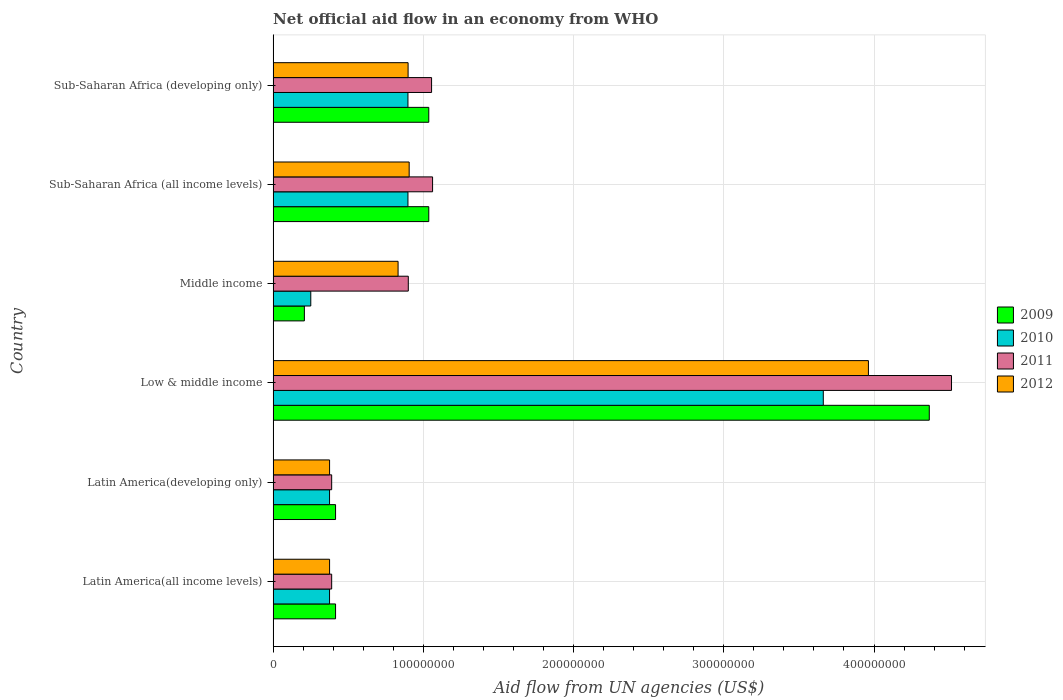How many groups of bars are there?
Ensure brevity in your answer.  6. How many bars are there on the 5th tick from the top?
Your answer should be very brief. 4. How many bars are there on the 2nd tick from the bottom?
Keep it short and to the point. 4. What is the label of the 1st group of bars from the top?
Provide a short and direct response. Sub-Saharan Africa (developing only). What is the net official aid flow in 2012 in Sub-Saharan Africa (developing only)?
Offer a terse response. 8.98e+07. Across all countries, what is the maximum net official aid flow in 2009?
Keep it short and to the point. 4.37e+08. Across all countries, what is the minimum net official aid flow in 2012?
Your answer should be very brief. 3.76e+07. In which country was the net official aid flow in 2012 minimum?
Provide a short and direct response. Latin America(all income levels). What is the total net official aid flow in 2011 in the graph?
Give a very brief answer. 8.31e+08. What is the difference between the net official aid flow in 2010 in Latin America(all income levels) and that in Sub-Saharan Africa (developing only)?
Keep it short and to the point. -5.22e+07. What is the difference between the net official aid flow in 2010 in Latin America(developing only) and the net official aid flow in 2009 in Middle income?
Your response must be concise. 1.68e+07. What is the average net official aid flow in 2010 per country?
Your answer should be very brief. 1.08e+08. What is the difference between the net official aid flow in 2010 and net official aid flow in 2012 in Middle income?
Make the answer very short. -5.81e+07. In how many countries, is the net official aid flow in 2012 greater than 40000000 US$?
Offer a terse response. 4. What is the ratio of the net official aid flow in 2010 in Latin America(developing only) to that in Sub-Saharan Africa (all income levels)?
Your answer should be very brief. 0.42. Is the net official aid flow in 2009 in Latin America(all income levels) less than that in Sub-Saharan Africa (all income levels)?
Provide a short and direct response. Yes. Is the difference between the net official aid flow in 2010 in Latin America(all income levels) and Latin America(developing only) greater than the difference between the net official aid flow in 2012 in Latin America(all income levels) and Latin America(developing only)?
Offer a terse response. No. What is the difference between the highest and the second highest net official aid flow in 2011?
Your response must be concise. 3.45e+08. What is the difference between the highest and the lowest net official aid flow in 2009?
Your answer should be very brief. 4.16e+08. In how many countries, is the net official aid flow in 2011 greater than the average net official aid flow in 2011 taken over all countries?
Give a very brief answer. 1. Is the sum of the net official aid flow in 2011 in Latin America(all income levels) and Latin America(developing only) greater than the maximum net official aid flow in 2012 across all countries?
Ensure brevity in your answer.  No. Is it the case that in every country, the sum of the net official aid flow in 2009 and net official aid flow in 2010 is greater than the sum of net official aid flow in 2012 and net official aid flow in 2011?
Make the answer very short. No. What does the 4th bar from the top in Low & middle income represents?
Offer a terse response. 2009. What does the 3rd bar from the bottom in Middle income represents?
Your response must be concise. 2011. How many bars are there?
Ensure brevity in your answer.  24. Where does the legend appear in the graph?
Your response must be concise. Center right. How many legend labels are there?
Ensure brevity in your answer.  4. How are the legend labels stacked?
Your answer should be compact. Vertical. What is the title of the graph?
Offer a very short reply. Net official aid flow in an economy from WHO. Does "1988" appear as one of the legend labels in the graph?
Your answer should be compact. No. What is the label or title of the X-axis?
Your answer should be very brief. Aid flow from UN agencies (US$). What is the Aid flow from UN agencies (US$) of 2009 in Latin America(all income levels)?
Offer a terse response. 4.16e+07. What is the Aid flow from UN agencies (US$) of 2010 in Latin America(all income levels)?
Ensure brevity in your answer.  3.76e+07. What is the Aid flow from UN agencies (US$) in 2011 in Latin America(all income levels)?
Your response must be concise. 3.90e+07. What is the Aid flow from UN agencies (US$) in 2012 in Latin America(all income levels)?
Keep it short and to the point. 3.76e+07. What is the Aid flow from UN agencies (US$) of 2009 in Latin America(developing only)?
Your answer should be compact. 4.16e+07. What is the Aid flow from UN agencies (US$) of 2010 in Latin America(developing only)?
Your answer should be compact. 3.76e+07. What is the Aid flow from UN agencies (US$) of 2011 in Latin America(developing only)?
Give a very brief answer. 3.90e+07. What is the Aid flow from UN agencies (US$) in 2012 in Latin America(developing only)?
Keep it short and to the point. 3.76e+07. What is the Aid flow from UN agencies (US$) of 2009 in Low & middle income?
Give a very brief answer. 4.37e+08. What is the Aid flow from UN agencies (US$) of 2010 in Low & middle income?
Your answer should be compact. 3.66e+08. What is the Aid flow from UN agencies (US$) of 2011 in Low & middle income?
Your answer should be compact. 4.52e+08. What is the Aid flow from UN agencies (US$) in 2012 in Low & middle income?
Your answer should be very brief. 3.96e+08. What is the Aid flow from UN agencies (US$) of 2009 in Middle income?
Your answer should be very brief. 2.08e+07. What is the Aid flow from UN agencies (US$) of 2010 in Middle income?
Keep it short and to the point. 2.51e+07. What is the Aid flow from UN agencies (US$) of 2011 in Middle income?
Your answer should be compact. 9.00e+07. What is the Aid flow from UN agencies (US$) in 2012 in Middle income?
Keep it short and to the point. 8.32e+07. What is the Aid flow from UN agencies (US$) of 2009 in Sub-Saharan Africa (all income levels)?
Provide a succinct answer. 1.04e+08. What is the Aid flow from UN agencies (US$) of 2010 in Sub-Saharan Africa (all income levels)?
Your answer should be very brief. 8.98e+07. What is the Aid flow from UN agencies (US$) in 2011 in Sub-Saharan Africa (all income levels)?
Make the answer very short. 1.06e+08. What is the Aid flow from UN agencies (US$) of 2012 in Sub-Saharan Africa (all income levels)?
Provide a short and direct response. 9.06e+07. What is the Aid flow from UN agencies (US$) of 2009 in Sub-Saharan Africa (developing only)?
Ensure brevity in your answer.  1.04e+08. What is the Aid flow from UN agencies (US$) in 2010 in Sub-Saharan Africa (developing only)?
Provide a short and direct response. 8.98e+07. What is the Aid flow from UN agencies (US$) of 2011 in Sub-Saharan Africa (developing only)?
Provide a succinct answer. 1.05e+08. What is the Aid flow from UN agencies (US$) of 2012 in Sub-Saharan Africa (developing only)?
Offer a terse response. 8.98e+07. Across all countries, what is the maximum Aid flow from UN agencies (US$) of 2009?
Offer a terse response. 4.37e+08. Across all countries, what is the maximum Aid flow from UN agencies (US$) of 2010?
Offer a terse response. 3.66e+08. Across all countries, what is the maximum Aid flow from UN agencies (US$) in 2011?
Your response must be concise. 4.52e+08. Across all countries, what is the maximum Aid flow from UN agencies (US$) in 2012?
Make the answer very short. 3.96e+08. Across all countries, what is the minimum Aid flow from UN agencies (US$) of 2009?
Make the answer very short. 2.08e+07. Across all countries, what is the minimum Aid flow from UN agencies (US$) of 2010?
Offer a terse response. 2.51e+07. Across all countries, what is the minimum Aid flow from UN agencies (US$) in 2011?
Your answer should be compact. 3.90e+07. Across all countries, what is the minimum Aid flow from UN agencies (US$) of 2012?
Make the answer very short. 3.76e+07. What is the total Aid flow from UN agencies (US$) of 2009 in the graph?
Make the answer very short. 7.48e+08. What is the total Aid flow from UN agencies (US$) in 2010 in the graph?
Provide a succinct answer. 6.46e+08. What is the total Aid flow from UN agencies (US$) in 2011 in the graph?
Make the answer very short. 8.31e+08. What is the total Aid flow from UN agencies (US$) in 2012 in the graph?
Give a very brief answer. 7.35e+08. What is the difference between the Aid flow from UN agencies (US$) of 2010 in Latin America(all income levels) and that in Latin America(developing only)?
Keep it short and to the point. 0. What is the difference between the Aid flow from UN agencies (US$) of 2011 in Latin America(all income levels) and that in Latin America(developing only)?
Provide a succinct answer. 0. What is the difference between the Aid flow from UN agencies (US$) in 2009 in Latin America(all income levels) and that in Low & middle income?
Your answer should be compact. -3.95e+08. What is the difference between the Aid flow from UN agencies (US$) in 2010 in Latin America(all income levels) and that in Low & middle income?
Provide a succinct answer. -3.29e+08. What is the difference between the Aid flow from UN agencies (US$) in 2011 in Latin America(all income levels) and that in Low & middle income?
Offer a terse response. -4.13e+08. What is the difference between the Aid flow from UN agencies (US$) in 2012 in Latin America(all income levels) and that in Low & middle income?
Make the answer very short. -3.59e+08. What is the difference between the Aid flow from UN agencies (US$) of 2009 in Latin America(all income levels) and that in Middle income?
Your answer should be very brief. 2.08e+07. What is the difference between the Aid flow from UN agencies (US$) of 2010 in Latin America(all income levels) and that in Middle income?
Offer a terse response. 1.25e+07. What is the difference between the Aid flow from UN agencies (US$) in 2011 in Latin America(all income levels) and that in Middle income?
Offer a terse response. -5.10e+07. What is the difference between the Aid flow from UN agencies (US$) of 2012 in Latin America(all income levels) and that in Middle income?
Give a very brief answer. -4.56e+07. What is the difference between the Aid flow from UN agencies (US$) in 2009 in Latin America(all income levels) and that in Sub-Saharan Africa (all income levels)?
Ensure brevity in your answer.  -6.20e+07. What is the difference between the Aid flow from UN agencies (US$) in 2010 in Latin America(all income levels) and that in Sub-Saharan Africa (all income levels)?
Your response must be concise. -5.22e+07. What is the difference between the Aid flow from UN agencies (US$) of 2011 in Latin America(all income levels) and that in Sub-Saharan Africa (all income levels)?
Offer a terse response. -6.72e+07. What is the difference between the Aid flow from UN agencies (US$) of 2012 in Latin America(all income levels) and that in Sub-Saharan Africa (all income levels)?
Keep it short and to the point. -5.30e+07. What is the difference between the Aid flow from UN agencies (US$) of 2009 in Latin America(all income levels) and that in Sub-Saharan Africa (developing only)?
Your answer should be compact. -6.20e+07. What is the difference between the Aid flow from UN agencies (US$) in 2010 in Latin America(all income levels) and that in Sub-Saharan Africa (developing only)?
Offer a terse response. -5.22e+07. What is the difference between the Aid flow from UN agencies (US$) in 2011 in Latin America(all income levels) and that in Sub-Saharan Africa (developing only)?
Offer a very short reply. -6.65e+07. What is the difference between the Aid flow from UN agencies (US$) of 2012 in Latin America(all income levels) and that in Sub-Saharan Africa (developing only)?
Provide a short and direct response. -5.23e+07. What is the difference between the Aid flow from UN agencies (US$) of 2009 in Latin America(developing only) and that in Low & middle income?
Make the answer very short. -3.95e+08. What is the difference between the Aid flow from UN agencies (US$) in 2010 in Latin America(developing only) and that in Low & middle income?
Ensure brevity in your answer.  -3.29e+08. What is the difference between the Aid flow from UN agencies (US$) in 2011 in Latin America(developing only) and that in Low & middle income?
Offer a very short reply. -4.13e+08. What is the difference between the Aid flow from UN agencies (US$) in 2012 in Latin America(developing only) and that in Low & middle income?
Your answer should be compact. -3.59e+08. What is the difference between the Aid flow from UN agencies (US$) of 2009 in Latin America(developing only) and that in Middle income?
Ensure brevity in your answer.  2.08e+07. What is the difference between the Aid flow from UN agencies (US$) in 2010 in Latin America(developing only) and that in Middle income?
Give a very brief answer. 1.25e+07. What is the difference between the Aid flow from UN agencies (US$) in 2011 in Latin America(developing only) and that in Middle income?
Offer a terse response. -5.10e+07. What is the difference between the Aid flow from UN agencies (US$) of 2012 in Latin America(developing only) and that in Middle income?
Offer a very short reply. -4.56e+07. What is the difference between the Aid flow from UN agencies (US$) in 2009 in Latin America(developing only) and that in Sub-Saharan Africa (all income levels)?
Your response must be concise. -6.20e+07. What is the difference between the Aid flow from UN agencies (US$) of 2010 in Latin America(developing only) and that in Sub-Saharan Africa (all income levels)?
Your response must be concise. -5.22e+07. What is the difference between the Aid flow from UN agencies (US$) in 2011 in Latin America(developing only) and that in Sub-Saharan Africa (all income levels)?
Give a very brief answer. -6.72e+07. What is the difference between the Aid flow from UN agencies (US$) of 2012 in Latin America(developing only) and that in Sub-Saharan Africa (all income levels)?
Your answer should be compact. -5.30e+07. What is the difference between the Aid flow from UN agencies (US$) in 2009 in Latin America(developing only) and that in Sub-Saharan Africa (developing only)?
Your response must be concise. -6.20e+07. What is the difference between the Aid flow from UN agencies (US$) of 2010 in Latin America(developing only) and that in Sub-Saharan Africa (developing only)?
Provide a short and direct response. -5.22e+07. What is the difference between the Aid flow from UN agencies (US$) in 2011 in Latin America(developing only) and that in Sub-Saharan Africa (developing only)?
Your answer should be very brief. -6.65e+07. What is the difference between the Aid flow from UN agencies (US$) of 2012 in Latin America(developing only) and that in Sub-Saharan Africa (developing only)?
Give a very brief answer. -5.23e+07. What is the difference between the Aid flow from UN agencies (US$) of 2009 in Low & middle income and that in Middle income?
Your answer should be very brief. 4.16e+08. What is the difference between the Aid flow from UN agencies (US$) in 2010 in Low & middle income and that in Middle income?
Provide a short and direct response. 3.41e+08. What is the difference between the Aid flow from UN agencies (US$) in 2011 in Low & middle income and that in Middle income?
Make the answer very short. 3.62e+08. What is the difference between the Aid flow from UN agencies (US$) in 2012 in Low & middle income and that in Middle income?
Offer a very short reply. 3.13e+08. What is the difference between the Aid flow from UN agencies (US$) in 2009 in Low & middle income and that in Sub-Saharan Africa (all income levels)?
Your answer should be compact. 3.33e+08. What is the difference between the Aid flow from UN agencies (US$) of 2010 in Low & middle income and that in Sub-Saharan Africa (all income levels)?
Provide a succinct answer. 2.76e+08. What is the difference between the Aid flow from UN agencies (US$) in 2011 in Low & middle income and that in Sub-Saharan Africa (all income levels)?
Your response must be concise. 3.45e+08. What is the difference between the Aid flow from UN agencies (US$) in 2012 in Low & middle income and that in Sub-Saharan Africa (all income levels)?
Give a very brief answer. 3.06e+08. What is the difference between the Aid flow from UN agencies (US$) of 2009 in Low & middle income and that in Sub-Saharan Africa (developing only)?
Provide a short and direct response. 3.33e+08. What is the difference between the Aid flow from UN agencies (US$) of 2010 in Low & middle income and that in Sub-Saharan Africa (developing only)?
Provide a short and direct response. 2.76e+08. What is the difference between the Aid flow from UN agencies (US$) of 2011 in Low & middle income and that in Sub-Saharan Africa (developing only)?
Your answer should be compact. 3.46e+08. What is the difference between the Aid flow from UN agencies (US$) in 2012 in Low & middle income and that in Sub-Saharan Africa (developing only)?
Your answer should be compact. 3.06e+08. What is the difference between the Aid flow from UN agencies (US$) of 2009 in Middle income and that in Sub-Saharan Africa (all income levels)?
Keep it short and to the point. -8.28e+07. What is the difference between the Aid flow from UN agencies (US$) in 2010 in Middle income and that in Sub-Saharan Africa (all income levels)?
Keep it short and to the point. -6.47e+07. What is the difference between the Aid flow from UN agencies (US$) of 2011 in Middle income and that in Sub-Saharan Africa (all income levels)?
Keep it short and to the point. -1.62e+07. What is the difference between the Aid flow from UN agencies (US$) in 2012 in Middle income and that in Sub-Saharan Africa (all income levels)?
Ensure brevity in your answer.  -7.39e+06. What is the difference between the Aid flow from UN agencies (US$) of 2009 in Middle income and that in Sub-Saharan Africa (developing only)?
Your answer should be very brief. -8.28e+07. What is the difference between the Aid flow from UN agencies (US$) of 2010 in Middle income and that in Sub-Saharan Africa (developing only)?
Your answer should be very brief. -6.47e+07. What is the difference between the Aid flow from UN agencies (US$) in 2011 in Middle income and that in Sub-Saharan Africa (developing only)?
Offer a very short reply. -1.55e+07. What is the difference between the Aid flow from UN agencies (US$) in 2012 in Middle income and that in Sub-Saharan Africa (developing only)?
Provide a succinct answer. -6.67e+06. What is the difference between the Aid flow from UN agencies (US$) of 2009 in Sub-Saharan Africa (all income levels) and that in Sub-Saharan Africa (developing only)?
Keep it short and to the point. 0. What is the difference between the Aid flow from UN agencies (US$) in 2011 in Sub-Saharan Africa (all income levels) and that in Sub-Saharan Africa (developing only)?
Give a very brief answer. 6.70e+05. What is the difference between the Aid flow from UN agencies (US$) in 2012 in Sub-Saharan Africa (all income levels) and that in Sub-Saharan Africa (developing only)?
Provide a short and direct response. 7.20e+05. What is the difference between the Aid flow from UN agencies (US$) of 2009 in Latin America(all income levels) and the Aid flow from UN agencies (US$) of 2010 in Latin America(developing only)?
Offer a terse response. 4.01e+06. What is the difference between the Aid flow from UN agencies (US$) in 2009 in Latin America(all income levels) and the Aid flow from UN agencies (US$) in 2011 in Latin America(developing only)?
Your answer should be very brief. 2.59e+06. What is the difference between the Aid flow from UN agencies (US$) in 2009 in Latin America(all income levels) and the Aid flow from UN agencies (US$) in 2012 in Latin America(developing only)?
Make the answer very short. 3.99e+06. What is the difference between the Aid flow from UN agencies (US$) of 2010 in Latin America(all income levels) and the Aid flow from UN agencies (US$) of 2011 in Latin America(developing only)?
Provide a succinct answer. -1.42e+06. What is the difference between the Aid flow from UN agencies (US$) in 2011 in Latin America(all income levels) and the Aid flow from UN agencies (US$) in 2012 in Latin America(developing only)?
Make the answer very short. 1.40e+06. What is the difference between the Aid flow from UN agencies (US$) of 2009 in Latin America(all income levels) and the Aid flow from UN agencies (US$) of 2010 in Low & middle income?
Give a very brief answer. -3.25e+08. What is the difference between the Aid flow from UN agencies (US$) of 2009 in Latin America(all income levels) and the Aid flow from UN agencies (US$) of 2011 in Low & middle income?
Provide a succinct answer. -4.10e+08. What is the difference between the Aid flow from UN agencies (US$) of 2009 in Latin America(all income levels) and the Aid flow from UN agencies (US$) of 2012 in Low & middle income?
Provide a short and direct response. -3.55e+08. What is the difference between the Aid flow from UN agencies (US$) of 2010 in Latin America(all income levels) and the Aid flow from UN agencies (US$) of 2011 in Low & middle income?
Provide a short and direct response. -4.14e+08. What is the difference between the Aid flow from UN agencies (US$) in 2010 in Latin America(all income levels) and the Aid flow from UN agencies (US$) in 2012 in Low & middle income?
Make the answer very short. -3.59e+08. What is the difference between the Aid flow from UN agencies (US$) in 2011 in Latin America(all income levels) and the Aid flow from UN agencies (US$) in 2012 in Low & middle income?
Your answer should be compact. -3.57e+08. What is the difference between the Aid flow from UN agencies (US$) in 2009 in Latin America(all income levels) and the Aid flow from UN agencies (US$) in 2010 in Middle income?
Your answer should be very brief. 1.65e+07. What is the difference between the Aid flow from UN agencies (US$) in 2009 in Latin America(all income levels) and the Aid flow from UN agencies (US$) in 2011 in Middle income?
Offer a very short reply. -4.84e+07. What is the difference between the Aid flow from UN agencies (US$) in 2009 in Latin America(all income levels) and the Aid flow from UN agencies (US$) in 2012 in Middle income?
Provide a short and direct response. -4.16e+07. What is the difference between the Aid flow from UN agencies (US$) in 2010 in Latin America(all income levels) and the Aid flow from UN agencies (US$) in 2011 in Middle income?
Your answer should be compact. -5.24e+07. What is the difference between the Aid flow from UN agencies (US$) in 2010 in Latin America(all income levels) and the Aid flow from UN agencies (US$) in 2012 in Middle income?
Make the answer very short. -4.56e+07. What is the difference between the Aid flow from UN agencies (US$) of 2011 in Latin America(all income levels) and the Aid flow from UN agencies (US$) of 2012 in Middle income?
Offer a terse response. -4.42e+07. What is the difference between the Aid flow from UN agencies (US$) of 2009 in Latin America(all income levels) and the Aid flow from UN agencies (US$) of 2010 in Sub-Saharan Africa (all income levels)?
Provide a short and direct response. -4.82e+07. What is the difference between the Aid flow from UN agencies (US$) in 2009 in Latin America(all income levels) and the Aid flow from UN agencies (US$) in 2011 in Sub-Saharan Africa (all income levels)?
Provide a short and direct response. -6.46e+07. What is the difference between the Aid flow from UN agencies (US$) of 2009 in Latin America(all income levels) and the Aid flow from UN agencies (US$) of 2012 in Sub-Saharan Africa (all income levels)?
Provide a succinct answer. -4.90e+07. What is the difference between the Aid flow from UN agencies (US$) of 2010 in Latin America(all income levels) and the Aid flow from UN agencies (US$) of 2011 in Sub-Saharan Africa (all income levels)?
Offer a very short reply. -6.86e+07. What is the difference between the Aid flow from UN agencies (US$) of 2010 in Latin America(all income levels) and the Aid flow from UN agencies (US$) of 2012 in Sub-Saharan Africa (all income levels)?
Provide a succinct answer. -5.30e+07. What is the difference between the Aid flow from UN agencies (US$) in 2011 in Latin America(all income levels) and the Aid flow from UN agencies (US$) in 2012 in Sub-Saharan Africa (all income levels)?
Your response must be concise. -5.16e+07. What is the difference between the Aid flow from UN agencies (US$) of 2009 in Latin America(all income levels) and the Aid flow from UN agencies (US$) of 2010 in Sub-Saharan Africa (developing only)?
Make the answer very short. -4.82e+07. What is the difference between the Aid flow from UN agencies (US$) in 2009 in Latin America(all income levels) and the Aid flow from UN agencies (US$) in 2011 in Sub-Saharan Africa (developing only)?
Your response must be concise. -6.39e+07. What is the difference between the Aid flow from UN agencies (US$) in 2009 in Latin America(all income levels) and the Aid flow from UN agencies (US$) in 2012 in Sub-Saharan Africa (developing only)?
Your answer should be very brief. -4.83e+07. What is the difference between the Aid flow from UN agencies (US$) of 2010 in Latin America(all income levels) and the Aid flow from UN agencies (US$) of 2011 in Sub-Saharan Africa (developing only)?
Provide a short and direct response. -6.79e+07. What is the difference between the Aid flow from UN agencies (US$) of 2010 in Latin America(all income levels) and the Aid flow from UN agencies (US$) of 2012 in Sub-Saharan Africa (developing only)?
Keep it short and to the point. -5.23e+07. What is the difference between the Aid flow from UN agencies (US$) in 2011 in Latin America(all income levels) and the Aid flow from UN agencies (US$) in 2012 in Sub-Saharan Africa (developing only)?
Provide a short and direct response. -5.09e+07. What is the difference between the Aid flow from UN agencies (US$) in 2009 in Latin America(developing only) and the Aid flow from UN agencies (US$) in 2010 in Low & middle income?
Your response must be concise. -3.25e+08. What is the difference between the Aid flow from UN agencies (US$) of 2009 in Latin America(developing only) and the Aid flow from UN agencies (US$) of 2011 in Low & middle income?
Keep it short and to the point. -4.10e+08. What is the difference between the Aid flow from UN agencies (US$) in 2009 in Latin America(developing only) and the Aid flow from UN agencies (US$) in 2012 in Low & middle income?
Provide a short and direct response. -3.55e+08. What is the difference between the Aid flow from UN agencies (US$) in 2010 in Latin America(developing only) and the Aid flow from UN agencies (US$) in 2011 in Low & middle income?
Offer a terse response. -4.14e+08. What is the difference between the Aid flow from UN agencies (US$) in 2010 in Latin America(developing only) and the Aid flow from UN agencies (US$) in 2012 in Low & middle income?
Keep it short and to the point. -3.59e+08. What is the difference between the Aid flow from UN agencies (US$) in 2011 in Latin America(developing only) and the Aid flow from UN agencies (US$) in 2012 in Low & middle income?
Offer a very short reply. -3.57e+08. What is the difference between the Aid flow from UN agencies (US$) of 2009 in Latin America(developing only) and the Aid flow from UN agencies (US$) of 2010 in Middle income?
Your response must be concise. 1.65e+07. What is the difference between the Aid flow from UN agencies (US$) in 2009 in Latin America(developing only) and the Aid flow from UN agencies (US$) in 2011 in Middle income?
Offer a terse response. -4.84e+07. What is the difference between the Aid flow from UN agencies (US$) in 2009 in Latin America(developing only) and the Aid flow from UN agencies (US$) in 2012 in Middle income?
Offer a very short reply. -4.16e+07. What is the difference between the Aid flow from UN agencies (US$) in 2010 in Latin America(developing only) and the Aid flow from UN agencies (US$) in 2011 in Middle income?
Your answer should be very brief. -5.24e+07. What is the difference between the Aid flow from UN agencies (US$) of 2010 in Latin America(developing only) and the Aid flow from UN agencies (US$) of 2012 in Middle income?
Your answer should be compact. -4.56e+07. What is the difference between the Aid flow from UN agencies (US$) of 2011 in Latin America(developing only) and the Aid flow from UN agencies (US$) of 2012 in Middle income?
Offer a terse response. -4.42e+07. What is the difference between the Aid flow from UN agencies (US$) in 2009 in Latin America(developing only) and the Aid flow from UN agencies (US$) in 2010 in Sub-Saharan Africa (all income levels)?
Make the answer very short. -4.82e+07. What is the difference between the Aid flow from UN agencies (US$) of 2009 in Latin America(developing only) and the Aid flow from UN agencies (US$) of 2011 in Sub-Saharan Africa (all income levels)?
Provide a succinct answer. -6.46e+07. What is the difference between the Aid flow from UN agencies (US$) in 2009 in Latin America(developing only) and the Aid flow from UN agencies (US$) in 2012 in Sub-Saharan Africa (all income levels)?
Provide a short and direct response. -4.90e+07. What is the difference between the Aid flow from UN agencies (US$) in 2010 in Latin America(developing only) and the Aid flow from UN agencies (US$) in 2011 in Sub-Saharan Africa (all income levels)?
Your answer should be compact. -6.86e+07. What is the difference between the Aid flow from UN agencies (US$) of 2010 in Latin America(developing only) and the Aid flow from UN agencies (US$) of 2012 in Sub-Saharan Africa (all income levels)?
Ensure brevity in your answer.  -5.30e+07. What is the difference between the Aid flow from UN agencies (US$) of 2011 in Latin America(developing only) and the Aid flow from UN agencies (US$) of 2012 in Sub-Saharan Africa (all income levels)?
Your answer should be very brief. -5.16e+07. What is the difference between the Aid flow from UN agencies (US$) of 2009 in Latin America(developing only) and the Aid flow from UN agencies (US$) of 2010 in Sub-Saharan Africa (developing only)?
Offer a terse response. -4.82e+07. What is the difference between the Aid flow from UN agencies (US$) of 2009 in Latin America(developing only) and the Aid flow from UN agencies (US$) of 2011 in Sub-Saharan Africa (developing only)?
Provide a succinct answer. -6.39e+07. What is the difference between the Aid flow from UN agencies (US$) in 2009 in Latin America(developing only) and the Aid flow from UN agencies (US$) in 2012 in Sub-Saharan Africa (developing only)?
Make the answer very short. -4.83e+07. What is the difference between the Aid flow from UN agencies (US$) in 2010 in Latin America(developing only) and the Aid flow from UN agencies (US$) in 2011 in Sub-Saharan Africa (developing only)?
Ensure brevity in your answer.  -6.79e+07. What is the difference between the Aid flow from UN agencies (US$) of 2010 in Latin America(developing only) and the Aid flow from UN agencies (US$) of 2012 in Sub-Saharan Africa (developing only)?
Your answer should be compact. -5.23e+07. What is the difference between the Aid flow from UN agencies (US$) in 2011 in Latin America(developing only) and the Aid flow from UN agencies (US$) in 2012 in Sub-Saharan Africa (developing only)?
Your answer should be very brief. -5.09e+07. What is the difference between the Aid flow from UN agencies (US$) of 2009 in Low & middle income and the Aid flow from UN agencies (US$) of 2010 in Middle income?
Provide a short and direct response. 4.12e+08. What is the difference between the Aid flow from UN agencies (US$) in 2009 in Low & middle income and the Aid flow from UN agencies (US$) in 2011 in Middle income?
Offer a terse response. 3.47e+08. What is the difference between the Aid flow from UN agencies (US$) in 2009 in Low & middle income and the Aid flow from UN agencies (US$) in 2012 in Middle income?
Make the answer very short. 3.54e+08. What is the difference between the Aid flow from UN agencies (US$) in 2010 in Low & middle income and the Aid flow from UN agencies (US$) in 2011 in Middle income?
Offer a very short reply. 2.76e+08. What is the difference between the Aid flow from UN agencies (US$) in 2010 in Low & middle income and the Aid flow from UN agencies (US$) in 2012 in Middle income?
Provide a short and direct response. 2.83e+08. What is the difference between the Aid flow from UN agencies (US$) of 2011 in Low & middle income and the Aid flow from UN agencies (US$) of 2012 in Middle income?
Your answer should be compact. 3.68e+08. What is the difference between the Aid flow from UN agencies (US$) of 2009 in Low & middle income and the Aid flow from UN agencies (US$) of 2010 in Sub-Saharan Africa (all income levels)?
Keep it short and to the point. 3.47e+08. What is the difference between the Aid flow from UN agencies (US$) of 2009 in Low & middle income and the Aid flow from UN agencies (US$) of 2011 in Sub-Saharan Africa (all income levels)?
Offer a terse response. 3.31e+08. What is the difference between the Aid flow from UN agencies (US$) of 2009 in Low & middle income and the Aid flow from UN agencies (US$) of 2012 in Sub-Saharan Africa (all income levels)?
Your answer should be very brief. 3.46e+08. What is the difference between the Aid flow from UN agencies (US$) of 2010 in Low & middle income and the Aid flow from UN agencies (US$) of 2011 in Sub-Saharan Africa (all income levels)?
Give a very brief answer. 2.60e+08. What is the difference between the Aid flow from UN agencies (US$) in 2010 in Low & middle income and the Aid flow from UN agencies (US$) in 2012 in Sub-Saharan Africa (all income levels)?
Provide a succinct answer. 2.76e+08. What is the difference between the Aid flow from UN agencies (US$) of 2011 in Low & middle income and the Aid flow from UN agencies (US$) of 2012 in Sub-Saharan Africa (all income levels)?
Ensure brevity in your answer.  3.61e+08. What is the difference between the Aid flow from UN agencies (US$) in 2009 in Low & middle income and the Aid flow from UN agencies (US$) in 2010 in Sub-Saharan Africa (developing only)?
Ensure brevity in your answer.  3.47e+08. What is the difference between the Aid flow from UN agencies (US$) of 2009 in Low & middle income and the Aid flow from UN agencies (US$) of 2011 in Sub-Saharan Africa (developing only)?
Your response must be concise. 3.31e+08. What is the difference between the Aid flow from UN agencies (US$) of 2009 in Low & middle income and the Aid flow from UN agencies (US$) of 2012 in Sub-Saharan Africa (developing only)?
Offer a terse response. 3.47e+08. What is the difference between the Aid flow from UN agencies (US$) of 2010 in Low & middle income and the Aid flow from UN agencies (US$) of 2011 in Sub-Saharan Africa (developing only)?
Keep it short and to the point. 2.61e+08. What is the difference between the Aid flow from UN agencies (US$) of 2010 in Low & middle income and the Aid flow from UN agencies (US$) of 2012 in Sub-Saharan Africa (developing only)?
Ensure brevity in your answer.  2.76e+08. What is the difference between the Aid flow from UN agencies (US$) of 2011 in Low & middle income and the Aid flow from UN agencies (US$) of 2012 in Sub-Saharan Africa (developing only)?
Your answer should be very brief. 3.62e+08. What is the difference between the Aid flow from UN agencies (US$) of 2009 in Middle income and the Aid flow from UN agencies (US$) of 2010 in Sub-Saharan Africa (all income levels)?
Give a very brief answer. -6.90e+07. What is the difference between the Aid flow from UN agencies (US$) in 2009 in Middle income and the Aid flow from UN agencies (US$) in 2011 in Sub-Saharan Africa (all income levels)?
Make the answer very short. -8.54e+07. What is the difference between the Aid flow from UN agencies (US$) in 2009 in Middle income and the Aid flow from UN agencies (US$) in 2012 in Sub-Saharan Africa (all income levels)?
Your answer should be very brief. -6.98e+07. What is the difference between the Aid flow from UN agencies (US$) of 2010 in Middle income and the Aid flow from UN agencies (US$) of 2011 in Sub-Saharan Africa (all income levels)?
Keep it short and to the point. -8.11e+07. What is the difference between the Aid flow from UN agencies (US$) of 2010 in Middle income and the Aid flow from UN agencies (US$) of 2012 in Sub-Saharan Africa (all income levels)?
Give a very brief answer. -6.55e+07. What is the difference between the Aid flow from UN agencies (US$) of 2011 in Middle income and the Aid flow from UN agencies (US$) of 2012 in Sub-Saharan Africa (all income levels)?
Offer a very short reply. -5.90e+05. What is the difference between the Aid flow from UN agencies (US$) of 2009 in Middle income and the Aid flow from UN agencies (US$) of 2010 in Sub-Saharan Africa (developing only)?
Ensure brevity in your answer.  -6.90e+07. What is the difference between the Aid flow from UN agencies (US$) of 2009 in Middle income and the Aid flow from UN agencies (US$) of 2011 in Sub-Saharan Africa (developing only)?
Your answer should be compact. -8.47e+07. What is the difference between the Aid flow from UN agencies (US$) in 2009 in Middle income and the Aid flow from UN agencies (US$) in 2012 in Sub-Saharan Africa (developing only)?
Make the answer very short. -6.90e+07. What is the difference between the Aid flow from UN agencies (US$) in 2010 in Middle income and the Aid flow from UN agencies (US$) in 2011 in Sub-Saharan Africa (developing only)?
Keep it short and to the point. -8.04e+07. What is the difference between the Aid flow from UN agencies (US$) in 2010 in Middle income and the Aid flow from UN agencies (US$) in 2012 in Sub-Saharan Africa (developing only)?
Ensure brevity in your answer.  -6.48e+07. What is the difference between the Aid flow from UN agencies (US$) of 2011 in Middle income and the Aid flow from UN agencies (US$) of 2012 in Sub-Saharan Africa (developing only)?
Offer a terse response. 1.30e+05. What is the difference between the Aid flow from UN agencies (US$) of 2009 in Sub-Saharan Africa (all income levels) and the Aid flow from UN agencies (US$) of 2010 in Sub-Saharan Africa (developing only)?
Your answer should be very brief. 1.39e+07. What is the difference between the Aid flow from UN agencies (US$) in 2009 in Sub-Saharan Africa (all income levels) and the Aid flow from UN agencies (US$) in 2011 in Sub-Saharan Africa (developing only)?
Your answer should be very brief. -1.86e+06. What is the difference between the Aid flow from UN agencies (US$) of 2009 in Sub-Saharan Africa (all income levels) and the Aid flow from UN agencies (US$) of 2012 in Sub-Saharan Africa (developing only)?
Make the answer very short. 1.38e+07. What is the difference between the Aid flow from UN agencies (US$) in 2010 in Sub-Saharan Africa (all income levels) and the Aid flow from UN agencies (US$) in 2011 in Sub-Saharan Africa (developing only)?
Your response must be concise. -1.57e+07. What is the difference between the Aid flow from UN agencies (US$) in 2011 in Sub-Saharan Africa (all income levels) and the Aid flow from UN agencies (US$) in 2012 in Sub-Saharan Africa (developing only)?
Provide a succinct answer. 1.63e+07. What is the average Aid flow from UN agencies (US$) of 2009 per country?
Your answer should be very brief. 1.25e+08. What is the average Aid flow from UN agencies (US$) of 2010 per country?
Offer a very short reply. 1.08e+08. What is the average Aid flow from UN agencies (US$) in 2011 per country?
Your response must be concise. 1.39e+08. What is the average Aid flow from UN agencies (US$) in 2012 per country?
Make the answer very short. 1.23e+08. What is the difference between the Aid flow from UN agencies (US$) of 2009 and Aid flow from UN agencies (US$) of 2010 in Latin America(all income levels)?
Your answer should be compact. 4.01e+06. What is the difference between the Aid flow from UN agencies (US$) in 2009 and Aid flow from UN agencies (US$) in 2011 in Latin America(all income levels)?
Offer a very short reply. 2.59e+06. What is the difference between the Aid flow from UN agencies (US$) of 2009 and Aid flow from UN agencies (US$) of 2012 in Latin America(all income levels)?
Give a very brief answer. 3.99e+06. What is the difference between the Aid flow from UN agencies (US$) in 2010 and Aid flow from UN agencies (US$) in 2011 in Latin America(all income levels)?
Your answer should be very brief. -1.42e+06. What is the difference between the Aid flow from UN agencies (US$) in 2010 and Aid flow from UN agencies (US$) in 2012 in Latin America(all income levels)?
Your response must be concise. -2.00e+04. What is the difference between the Aid flow from UN agencies (US$) of 2011 and Aid flow from UN agencies (US$) of 2012 in Latin America(all income levels)?
Make the answer very short. 1.40e+06. What is the difference between the Aid flow from UN agencies (US$) in 2009 and Aid flow from UN agencies (US$) in 2010 in Latin America(developing only)?
Provide a succinct answer. 4.01e+06. What is the difference between the Aid flow from UN agencies (US$) in 2009 and Aid flow from UN agencies (US$) in 2011 in Latin America(developing only)?
Your answer should be compact. 2.59e+06. What is the difference between the Aid flow from UN agencies (US$) in 2009 and Aid flow from UN agencies (US$) in 2012 in Latin America(developing only)?
Make the answer very short. 3.99e+06. What is the difference between the Aid flow from UN agencies (US$) in 2010 and Aid flow from UN agencies (US$) in 2011 in Latin America(developing only)?
Make the answer very short. -1.42e+06. What is the difference between the Aid flow from UN agencies (US$) of 2010 and Aid flow from UN agencies (US$) of 2012 in Latin America(developing only)?
Offer a terse response. -2.00e+04. What is the difference between the Aid flow from UN agencies (US$) in 2011 and Aid flow from UN agencies (US$) in 2012 in Latin America(developing only)?
Ensure brevity in your answer.  1.40e+06. What is the difference between the Aid flow from UN agencies (US$) of 2009 and Aid flow from UN agencies (US$) of 2010 in Low & middle income?
Keep it short and to the point. 7.06e+07. What is the difference between the Aid flow from UN agencies (US$) of 2009 and Aid flow from UN agencies (US$) of 2011 in Low & middle income?
Provide a succinct answer. -1.48e+07. What is the difference between the Aid flow from UN agencies (US$) of 2009 and Aid flow from UN agencies (US$) of 2012 in Low & middle income?
Make the answer very short. 4.05e+07. What is the difference between the Aid flow from UN agencies (US$) of 2010 and Aid flow from UN agencies (US$) of 2011 in Low & middle income?
Your answer should be compact. -8.54e+07. What is the difference between the Aid flow from UN agencies (US$) of 2010 and Aid flow from UN agencies (US$) of 2012 in Low & middle income?
Make the answer very short. -3.00e+07. What is the difference between the Aid flow from UN agencies (US$) in 2011 and Aid flow from UN agencies (US$) in 2012 in Low & middle income?
Ensure brevity in your answer.  5.53e+07. What is the difference between the Aid flow from UN agencies (US$) in 2009 and Aid flow from UN agencies (US$) in 2010 in Middle income?
Keep it short and to the point. -4.27e+06. What is the difference between the Aid flow from UN agencies (US$) of 2009 and Aid flow from UN agencies (US$) of 2011 in Middle income?
Your answer should be compact. -6.92e+07. What is the difference between the Aid flow from UN agencies (US$) in 2009 and Aid flow from UN agencies (US$) in 2012 in Middle income?
Your response must be concise. -6.24e+07. What is the difference between the Aid flow from UN agencies (US$) in 2010 and Aid flow from UN agencies (US$) in 2011 in Middle income?
Your answer should be very brief. -6.49e+07. What is the difference between the Aid flow from UN agencies (US$) of 2010 and Aid flow from UN agencies (US$) of 2012 in Middle income?
Offer a very short reply. -5.81e+07. What is the difference between the Aid flow from UN agencies (US$) of 2011 and Aid flow from UN agencies (US$) of 2012 in Middle income?
Offer a very short reply. 6.80e+06. What is the difference between the Aid flow from UN agencies (US$) in 2009 and Aid flow from UN agencies (US$) in 2010 in Sub-Saharan Africa (all income levels)?
Offer a terse response. 1.39e+07. What is the difference between the Aid flow from UN agencies (US$) of 2009 and Aid flow from UN agencies (US$) of 2011 in Sub-Saharan Africa (all income levels)?
Provide a short and direct response. -2.53e+06. What is the difference between the Aid flow from UN agencies (US$) in 2009 and Aid flow from UN agencies (US$) in 2012 in Sub-Saharan Africa (all income levels)?
Offer a very short reply. 1.30e+07. What is the difference between the Aid flow from UN agencies (US$) of 2010 and Aid flow from UN agencies (US$) of 2011 in Sub-Saharan Africa (all income levels)?
Offer a very short reply. -1.64e+07. What is the difference between the Aid flow from UN agencies (US$) of 2010 and Aid flow from UN agencies (US$) of 2012 in Sub-Saharan Africa (all income levels)?
Give a very brief answer. -8.10e+05. What is the difference between the Aid flow from UN agencies (US$) in 2011 and Aid flow from UN agencies (US$) in 2012 in Sub-Saharan Africa (all income levels)?
Your answer should be very brief. 1.56e+07. What is the difference between the Aid flow from UN agencies (US$) of 2009 and Aid flow from UN agencies (US$) of 2010 in Sub-Saharan Africa (developing only)?
Provide a succinct answer. 1.39e+07. What is the difference between the Aid flow from UN agencies (US$) of 2009 and Aid flow from UN agencies (US$) of 2011 in Sub-Saharan Africa (developing only)?
Keep it short and to the point. -1.86e+06. What is the difference between the Aid flow from UN agencies (US$) of 2009 and Aid flow from UN agencies (US$) of 2012 in Sub-Saharan Africa (developing only)?
Keep it short and to the point. 1.38e+07. What is the difference between the Aid flow from UN agencies (US$) in 2010 and Aid flow from UN agencies (US$) in 2011 in Sub-Saharan Africa (developing only)?
Your answer should be very brief. -1.57e+07. What is the difference between the Aid flow from UN agencies (US$) in 2010 and Aid flow from UN agencies (US$) in 2012 in Sub-Saharan Africa (developing only)?
Give a very brief answer. -9.00e+04. What is the difference between the Aid flow from UN agencies (US$) in 2011 and Aid flow from UN agencies (US$) in 2012 in Sub-Saharan Africa (developing only)?
Provide a succinct answer. 1.56e+07. What is the ratio of the Aid flow from UN agencies (US$) of 2009 in Latin America(all income levels) to that in Latin America(developing only)?
Provide a short and direct response. 1. What is the ratio of the Aid flow from UN agencies (US$) of 2011 in Latin America(all income levels) to that in Latin America(developing only)?
Give a very brief answer. 1. What is the ratio of the Aid flow from UN agencies (US$) in 2009 in Latin America(all income levels) to that in Low & middle income?
Keep it short and to the point. 0.1. What is the ratio of the Aid flow from UN agencies (US$) in 2010 in Latin America(all income levels) to that in Low & middle income?
Your response must be concise. 0.1. What is the ratio of the Aid flow from UN agencies (US$) of 2011 in Latin America(all income levels) to that in Low & middle income?
Your response must be concise. 0.09. What is the ratio of the Aid flow from UN agencies (US$) of 2012 in Latin America(all income levels) to that in Low & middle income?
Offer a terse response. 0.09. What is the ratio of the Aid flow from UN agencies (US$) of 2009 in Latin America(all income levels) to that in Middle income?
Ensure brevity in your answer.  2. What is the ratio of the Aid flow from UN agencies (US$) in 2010 in Latin America(all income levels) to that in Middle income?
Ensure brevity in your answer.  1.5. What is the ratio of the Aid flow from UN agencies (US$) in 2011 in Latin America(all income levels) to that in Middle income?
Your answer should be compact. 0.43. What is the ratio of the Aid flow from UN agencies (US$) in 2012 in Latin America(all income levels) to that in Middle income?
Make the answer very short. 0.45. What is the ratio of the Aid flow from UN agencies (US$) of 2009 in Latin America(all income levels) to that in Sub-Saharan Africa (all income levels)?
Provide a short and direct response. 0.4. What is the ratio of the Aid flow from UN agencies (US$) of 2010 in Latin America(all income levels) to that in Sub-Saharan Africa (all income levels)?
Your response must be concise. 0.42. What is the ratio of the Aid flow from UN agencies (US$) of 2011 in Latin America(all income levels) to that in Sub-Saharan Africa (all income levels)?
Offer a terse response. 0.37. What is the ratio of the Aid flow from UN agencies (US$) of 2012 in Latin America(all income levels) to that in Sub-Saharan Africa (all income levels)?
Offer a very short reply. 0.41. What is the ratio of the Aid flow from UN agencies (US$) in 2009 in Latin America(all income levels) to that in Sub-Saharan Africa (developing only)?
Provide a succinct answer. 0.4. What is the ratio of the Aid flow from UN agencies (US$) of 2010 in Latin America(all income levels) to that in Sub-Saharan Africa (developing only)?
Make the answer very short. 0.42. What is the ratio of the Aid flow from UN agencies (US$) in 2011 in Latin America(all income levels) to that in Sub-Saharan Africa (developing only)?
Your answer should be compact. 0.37. What is the ratio of the Aid flow from UN agencies (US$) of 2012 in Latin America(all income levels) to that in Sub-Saharan Africa (developing only)?
Your response must be concise. 0.42. What is the ratio of the Aid flow from UN agencies (US$) in 2009 in Latin America(developing only) to that in Low & middle income?
Provide a short and direct response. 0.1. What is the ratio of the Aid flow from UN agencies (US$) of 2010 in Latin America(developing only) to that in Low & middle income?
Your answer should be compact. 0.1. What is the ratio of the Aid flow from UN agencies (US$) in 2011 in Latin America(developing only) to that in Low & middle income?
Make the answer very short. 0.09. What is the ratio of the Aid flow from UN agencies (US$) of 2012 in Latin America(developing only) to that in Low & middle income?
Provide a succinct answer. 0.09. What is the ratio of the Aid flow from UN agencies (US$) in 2009 in Latin America(developing only) to that in Middle income?
Your answer should be very brief. 2. What is the ratio of the Aid flow from UN agencies (US$) in 2010 in Latin America(developing only) to that in Middle income?
Your response must be concise. 1.5. What is the ratio of the Aid flow from UN agencies (US$) in 2011 in Latin America(developing only) to that in Middle income?
Provide a succinct answer. 0.43. What is the ratio of the Aid flow from UN agencies (US$) of 2012 in Latin America(developing only) to that in Middle income?
Ensure brevity in your answer.  0.45. What is the ratio of the Aid flow from UN agencies (US$) in 2009 in Latin America(developing only) to that in Sub-Saharan Africa (all income levels)?
Provide a short and direct response. 0.4. What is the ratio of the Aid flow from UN agencies (US$) in 2010 in Latin America(developing only) to that in Sub-Saharan Africa (all income levels)?
Your answer should be very brief. 0.42. What is the ratio of the Aid flow from UN agencies (US$) of 2011 in Latin America(developing only) to that in Sub-Saharan Africa (all income levels)?
Offer a very short reply. 0.37. What is the ratio of the Aid flow from UN agencies (US$) of 2012 in Latin America(developing only) to that in Sub-Saharan Africa (all income levels)?
Offer a terse response. 0.41. What is the ratio of the Aid flow from UN agencies (US$) in 2009 in Latin America(developing only) to that in Sub-Saharan Africa (developing only)?
Your answer should be very brief. 0.4. What is the ratio of the Aid flow from UN agencies (US$) of 2010 in Latin America(developing only) to that in Sub-Saharan Africa (developing only)?
Your response must be concise. 0.42. What is the ratio of the Aid flow from UN agencies (US$) in 2011 in Latin America(developing only) to that in Sub-Saharan Africa (developing only)?
Give a very brief answer. 0.37. What is the ratio of the Aid flow from UN agencies (US$) in 2012 in Latin America(developing only) to that in Sub-Saharan Africa (developing only)?
Your answer should be compact. 0.42. What is the ratio of the Aid flow from UN agencies (US$) of 2009 in Low & middle income to that in Middle income?
Offer a terse response. 21. What is the ratio of the Aid flow from UN agencies (US$) in 2010 in Low & middle income to that in Middle income?
Offer a terse response. 14.61. What is the ratio of the Aid flow from UN agencies (US$) in 2011 in Low & middle income to that in Middle income?
Ensure brevity in your answer.  5.02. What is the ratio of the Aid flow from UN agencies (US$) of 2012 in Low & middle income to that in Middle income?
Offer a terse response. 4.76. What is the ratio of the Aid flow from UN agencies (US$) in 2009 in Low & middle income to that in Sub-Saharan Africa (all income levels)?
Your answer should be compact. 4.22. What is the ratio of the Aid flow from UN agencies (US$) of 2010 in Low & middle income to that in Sub-Saharan Africa (all income levels)?
Offer a terse response. 4.08. What is the ratio of the Aid flow from UN agencies (US$) of 2011 in Low & middle income to that in Sub-Saharan Africa (all income levels)?
Offer a terse response. 4.25. What is the ratio of the Aid flow from UN agencies (US$) in 2012 in Low & middle income to that in Sub-Saharan Africa (all income levels)?
Offer a terse response. 4.38. What is the ratio of the Aid flow from UN agencies (US$) of 2009 in Low & middle income to that in Sub-Saharan Africa (developing only)?
Ensure brevity in your answer.  4.22. What is the ratio of the Aid flow from UN agencies (US$) of 2010 in Low & middle income to that in Sub-Saharan Africa (developing only)?
Provide a short and direct response. 4.08. What is the ratio of the Aid flow from UN agencies (US$) of 2011 in Low & middle income to that in Sub-Saharan Africa (developing only)?
Provide a succinct answer. 4.28. What is the ratio of the Aid flow from UN agencies (US$) in 2012 in Low & middle income to that in Sub-Saharan Africa (developing only)?
Provide a succinct answer. 4.41. What is the ratio of the Aid flow from UN agencies (US$) in 2009 in Middle income to that in Sub-Saharan Africa (all income levels)?
Ensure brevity in your answer.  0.2. What is the ratio of the Aid flow from UN agencies (US$) of 2010 in Middle income to that in Sub-Saharan Africa (all income levels)?
Your answer should be very brief. 0.28. What is the ratio of the Aid flow from UN agencies (US$) of 2011 in Middle income to that in Sub-Saharan Africa (all income levels)?
Your answer should be very brief. 0.85. What is the ratio of the Aid flow from UN agencies (US$) of 2012 in Middle income to that in Sub-Saharan Africa (all income levels)?
Your answer should be compact. 0.92. What is the ratio of the Aid flow from UN agencies (US$) in 2009 in Middle income to that in Sub-Saharan Africa (developing only)?
Your answer should be compact. 0.2. What is the ratio of the Aid flow from UN agencies (US$) of 2010 in Middle income to that in Sub-Saharan Africa (developing only)?
Provide a succinct answer. 0.28. What is the ratio of the Aid flow from UN agencies (US$) in 2011 in Middle income to that in Sub-Saharan Africa (developing only)?
Your answer should be very brief. 0.85. What is the ratio of the Aid flow from UN agencies (US$) in 2012 in Middle income to that in Sub-Saharan Africa (developing only)?
Your answer should be compact. 0.93. What is the ratio of the Aid flow from UN agencies (US$) of 2009 in Sub-Saharan Africa (all income levels) to that in Sub-Saharan Africa (developing only)?
Keep it short and to the point. 1. What is the ratio of the Aid flow from UN agencies (US$) in 2010 in Sub-Saharan Africa (all income levels) to that in Sub-Saharan Africa (developing only)?
Your response must be concise. 1. What is the ratio of the Aid flow from UN agencies (US$) in 2011 in Sub-Saharan Africa (all income levels) to that in Sub-Saharan Africa (developing only)?
Ensure brevity in your answer.  1.01. What is the ratio of the Aid flow from UN agencies (US$) of 2012 in Sub-Saharan Africa (all income levels) to that in Sub-Saharan Africa (developing only)?
Provide a short and direct response. 1.01. What is the difference between the highest and the second highest Aid flow from UN agencies (US$) in 2009?
Offer a terse response. 3.33e+08. What is the difference between the highest and the second highest Aid flow from UN agencies (US$) of 2010?
Offer a very short reply. 2.76e+08. What is the difference between the highest and the second highest Aid flow from UN agencies (US$) of 2011?
Offer a very short reply. 3.45e+08. What is the difference between the highest and the second highest Aid flow from UN agencies (US$) of 2012?
Your answer should be very brief. 3.06e+08. What is the difference between the highest and the lowest Aid flow from UN agencies (US$) in 2009?
Give a very brief answer. 4.16e+08. What is the difference between the highest and the lowest Aid flow from UN agencies (US$) in 2010?
Your answer should be very brief. 3.41e+08. What is the difference between the highest and the lowest Aid flow from UN agencies (US$) of 2011?
Your response must be concise. 4.13e+08. What is the difference between the highest and the lowest Aid flow from UN agencies (US$) in 2012?
Ensure brevity in your answer.  3.59e+08. 